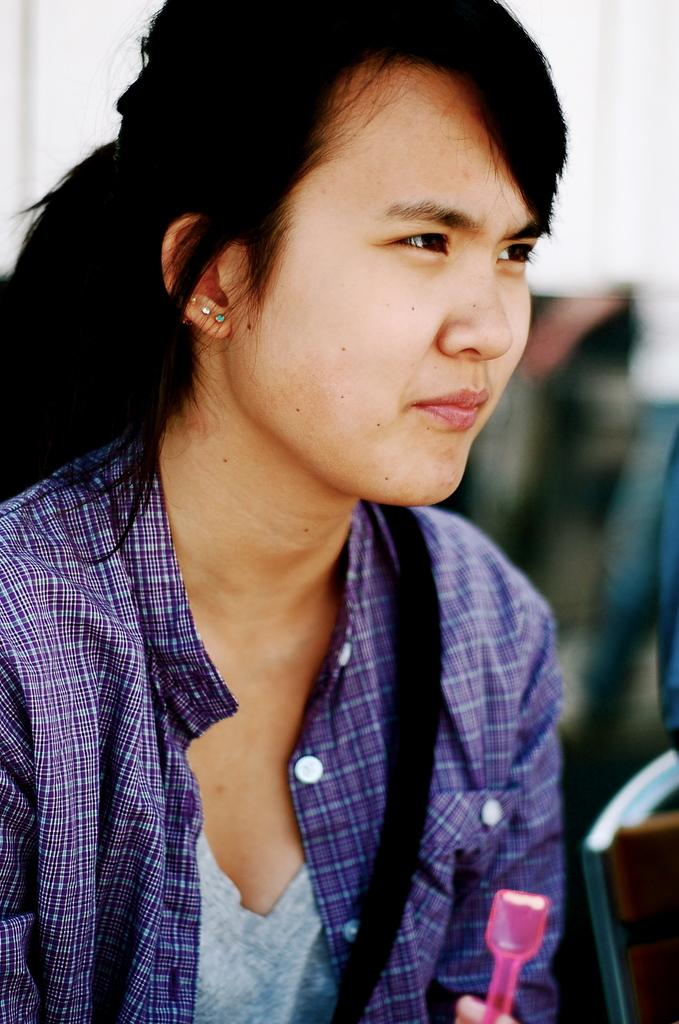What is the main subject of the image? There is a person in the image. What is the person wearing in the image? The person is wearing a purple and ash color dress. Can you describe the background of the image? The background of the image is blurred. What type of furniture can be seen in the background of the image? There is no furniture visible in the background of the image; it is blurred. 